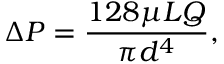<formula> <loc_0><loc_0><loc_500><loc_500>\Delta P = { \frac { 1 2 8 \mu L Q } { \pi d ^ { 4 } } } ,</formula> 